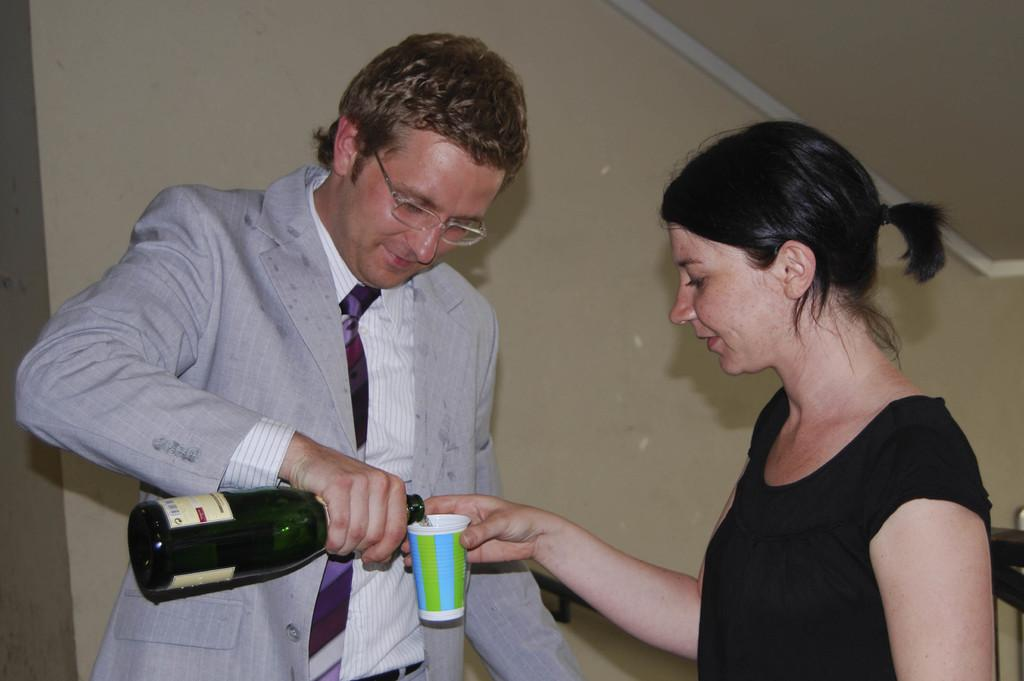What is the gender of the person in the image? There is a guy in the image. What is the guy wearing? The guy is wearing a suit. What object is the guy holding in the image? The guy is holding a bottle. Can you describe the woman in the image? There is a lady in the image, and she is wearing a black dress. Where is the flock of birds located in the image? There are no birds or flocks present in the image. 